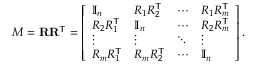Convert formula to latex. <formula><loc_0><loc_0><loc_500><loc_500>M = R R ^ { T } = \left [ \begin{array} { l l l l } { \mathbb { I } _ { n } } & { R _ { 1 } R _ { 2 } ^ { T } } & { \cdots } & { R _ { 1 } R _ { m } ^ { T } } \\ { R _ { 2 } R _ { 1 } ^ { T } } & { \mathbb { I } _ { n } } & { \cdots } & { R _ { 2 } R _ { m } ^ { T } } \\ { \vdots } & { \vdots } & { \ddots } & { \vdots } \\ { R _ { m } R _ { 1 } ^ { T } } & { R _ { m } R _ { 2 } ^ { T } } & { \cdots } & { \mathbb { I } _ { n } } \end{array} \right ] .</formula> 